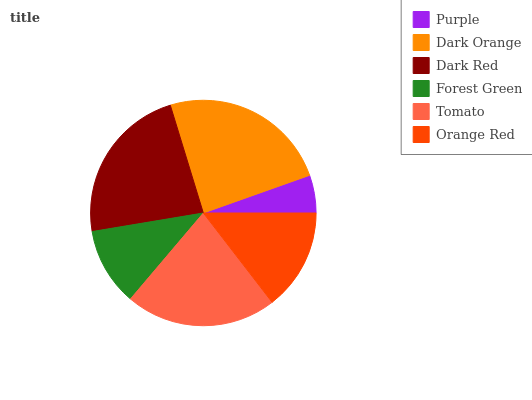Is Purple the minimum?
Answer yes or no. Yes. Is Dark Orange the maximum?
Answer yes or no. Yes. Is Dark Red the minimum?
Answer yes or no. No. Is Dark Red the maximum?
Answer yes or no. No. Is Dark Orange greater than Dark Red?
Answer yes or no. Yes. Is Dark Red less than Dark Orange?
Answer yes or no. Yes. Is Dark Red greater than Dark Orange?
Answer yes or no. No. Is Dark Orange less than Dark Red?
Answer yes or no. No. Is Tomato the high median?
Answer yes or no. Yes. Is Orange Red the low median?
Answer yes or no. Yes. Is Dark Orange the high median?
Answer yes or no. No. Is Forest Green the low median?
Answer yes or no. No. 